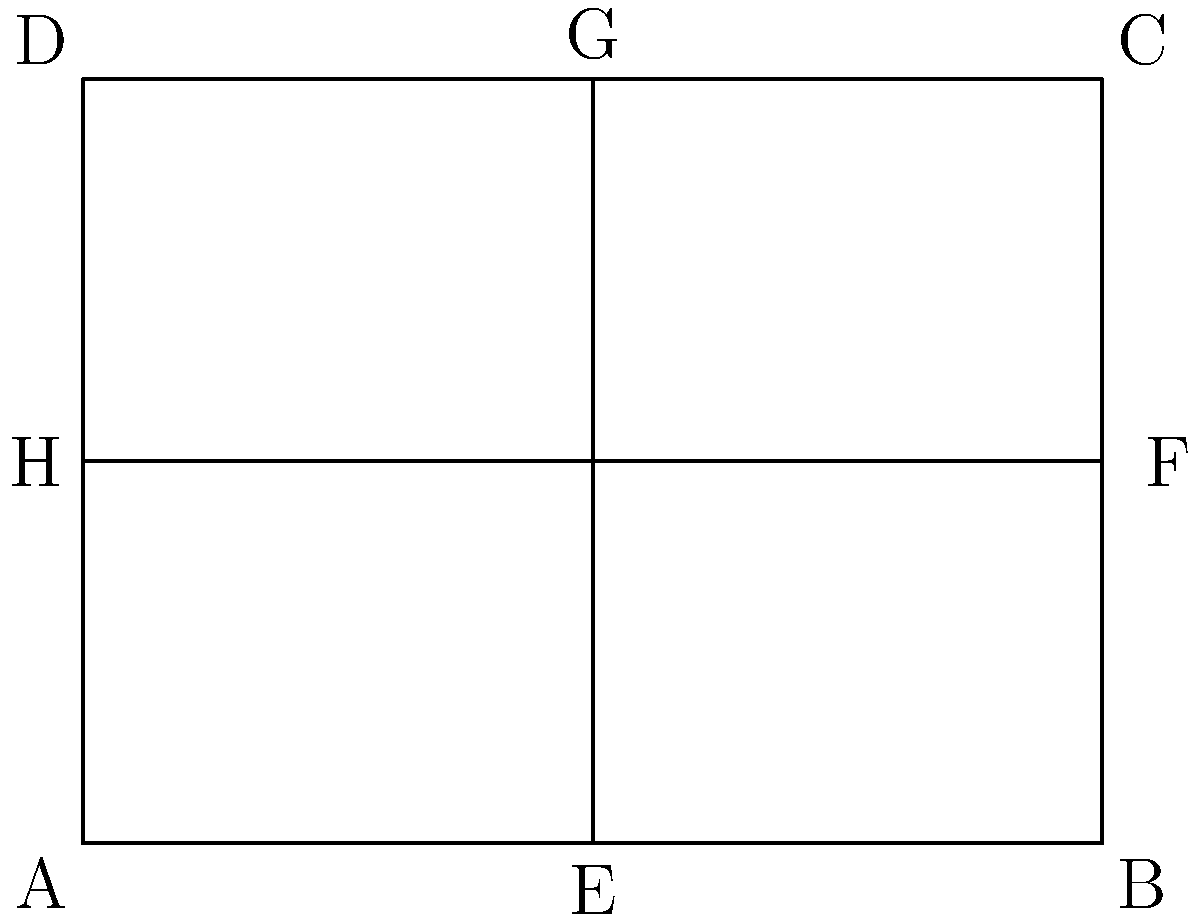The diagram represents a proposed layout for a rectangular building with dimensions 4 units by 3 units. To ensure equal access for all tenants, you want to determine the symmetry of the layout. How many lines of symmetry does this building layout have? To determine the number of lines of symmetry in the building layout, we need to analyze the shape and its internal structure:

1. First, let's consider the vertical line of symmetry:
   - The vertical line would pass through the center of the rectangle, from point E to point G.
   - This line divides the rectangle into two equal halves, and all internal features (diagonal lines) are mirrored on both sides.
   - Therefore, the vertical line EG is a line of symmetry.

2. Next, let's consider the horizontal line of symmetry:
   - The horizontal line would pass through the center of the rectangle, from point H to point F.
   - This line also divides the rectangle into two equal halves, and all internal features (diagonal lines) are mirrored above and below.
   - Therefore, the horizontal line HF is also a line of symmetry.

3. Now, let's consider the diagonal lines:
   - The diagonal lines AC and BD are not lines of symmetry because they do not divide the shape into mirror images.
   - If we were to fold the shape along these diagonals, the halves would not match up perfectly.

4. There are no other potential lines of symmetry to consider.

In conclusion, the building layout has two lines of symmetry: the vertical line EG and the horizontal line HF.
Answer: 2 lines of symmetry 